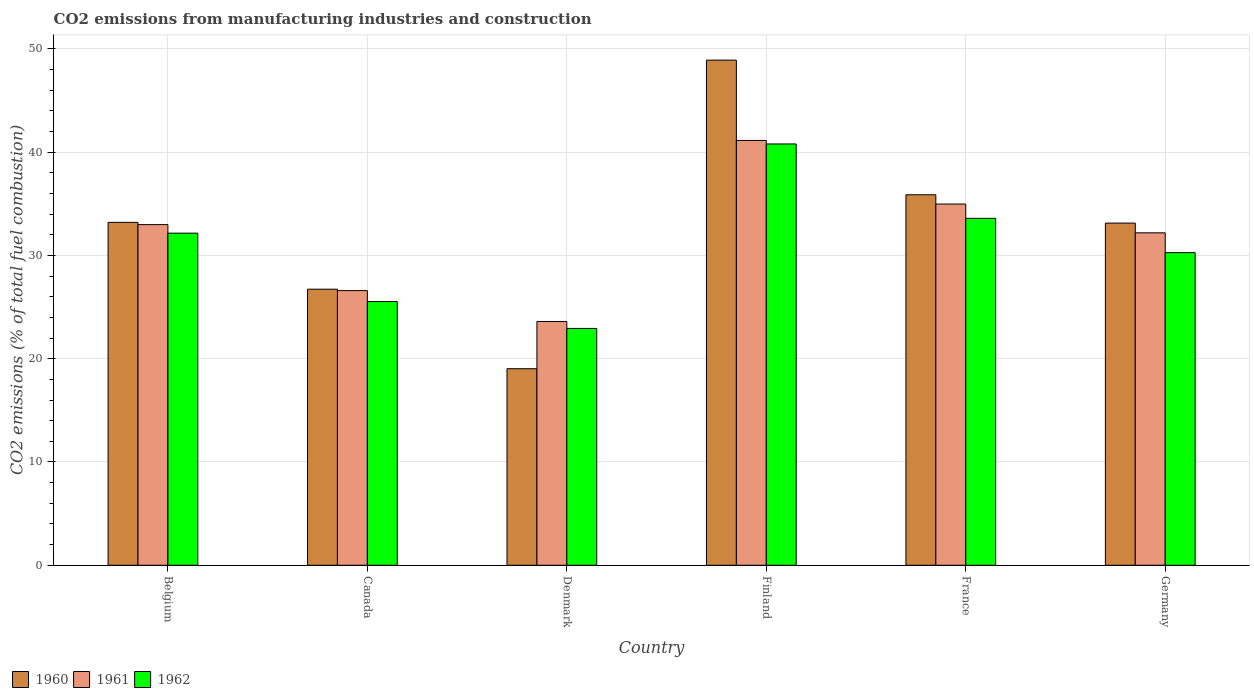How many different coloured bars are there?
Offer a very short reply. 3. Are the number of bars per tick equal to the number of legend labels?
Offer a very short reply. Yes. Are the number of bars on each tick of the X-axis equal?
Offer a very short reply. Yes. How many bars are there on the 2nd tick from the right?
Provide a short and direct response. 3. What is the label of the 3rd group of bars from the left?
Your answer should be very brief. Denmark. In how many cases, is the number of bars for a given country not equal to the number of legend labels?
Your response must be concise. 0. What is the amount of CO2 emitted in 1962 in Germany?
Keep it short and to the point. 30.27. Across all countries, what is the maximum amount of CO2 emitted in 1962?
Give a very brief answer. 40.79. Across all countries, what is the minimum amount of CO2 emitted in 1961?
Make the answer very short. 23.6. What is the total amount of CO2 emitted in 1961 in the graph?
Make the answer very short. 191.47. What is the difference between the amount of CO2 emitted in 1961 in Denmark and that in France?
Offer a very short reply. -11.37. What is the difference between the amount of CO2 emitted in 1960 in France and the amount of CO2 emitted in 1961 in Germany?
Provide a short and direct response. 3.68. What is the average amount of CO2 emitted in 1961 per country?
Offer a terse response. 31.91. What is the difference between the amount of CO2 emitted of/in 1962 and amount of CO2 emitted of/in 1961 in Finland?
Your answer should be compact. -0.34. What is the ratio of the amount of CO2 emitted in 1960 in France to that in Germany?
Offer a very short reply. 1.08. Is the amount of CO2 emitted in 1960 in Belgium less than that in Canada?
Your answer should be very brief. No. Is the difference between the amount of CO2 emitted in 1962 in Denmark and Germany greater than the difference between the amount of CO2 emitted in 1961 in Denmark and Germany?
Provide a succinct answer. Yes. What is the difference between the highest and the second highest amount of CO2 emitted in 1961?
Keep it short and to the point. -8.15. What is the difference between the highest and the lowest amount of CO2 emitted in 1961?
Offer a very short reply. 17.53. Is the sum of the amount of CO2 emitted in 1960 in France and Germany greater than the maximum amount of CO2 emitted in 1961 across all countries?
Offer a terse response. Yes. Is it the case that in every country, the sum of the amount of CO2 emitted in 1962 and amount of CO2 emitted in 1960 is greater than the amount of CO2 emitted in 1961?
Make the answer very short. Yes. Are all the bars in the graph horizontal?
Provide a short and direct response. No. Does the graph contain any zero values?
Ensure brevity in your answer.  No. How many legend labels are there?
Make the answer very short. 3. How are the legend labels stacked?
Your response must be concise. Horizontal. What is the title of the graph?
Offer a terse response. CO2 emissions from manufacturing industries and construction. Does "1960" appear as one of the legend labels in the graph?
Provide a succinct answer. Yes. What is the label or title of the Y-axis?
Keep it short and to the point. CO2 emissions (% of total fuel combustion). What is the CO2 emissions (% of total fuel combustion) in 1960 in Belgium?
Give a very brief answer. 33.2. What is the CO2 emissions (% of total fuel combustion) in 1961 in Belgium?
Provide a short and direct response. 32.98. What is the CO2 emissions (% of total fuel combustion) in 1962 in Belgium?
Your answer should be compact. 32.16. What is the CO2 emissions (% of total fuel combustion) in 1960 in Canada?
Make the answer very short. 26.73. What is the CO2 emissions (% of total fuel combustion) in 1961 in Canada?
Give a very brief answer. 26.59. What is the CO2 emissions (% of total fuel combustion) in 1962 in Canada?
Make the answer very short. 25.53. What is the CO2 emissions (% of total fuel combustion) of 1960 in Denmark?
Provide a short and direct response. 19.03. What is the CO2 emissions (% of total fuel combustion) in 1961 in Denmark?
Keep it short and to the point. 23.6. What is the CO2 emissions (% of total fuel combustion) of 1962 in Denmark?
Your answer should be compact. 22.93. What is the CO2 emissions (% of total fuel combustion) of 1960 in Finland?
Your response must be concise. 48.91. What is the CO2 emissions (% of total fuel combustion) in 1961 in Finland?
Offer a very short reply. 41.13. What is the CO2 emissions (% of total fuel combustion) in 1962 in Finland?
Your answer should be very brief. 40.79. What is the CO2 emissions (% of total fuel combustion) of 1960 in France?
Your answer should be very brief. 35.87. What is the CO2 emissions (% of total fuel combustion) in 1961 in France?
Ensure brevity in your answer.  34.98. What is the CO2 emissions (% of total fuel combustion) in 1962 in France?
Your answer should be very brief. 33.59. What is the CO2 emissions (% of total fuel combustion) of 1960 in Germany?
Offer a terse response. 33.13. What is the CO2 emissions (% of total fuel combustion) in 1961 in Germany?
Offer a very short reply. 32.19. What is the CO2 emissions (% of total fuel combustion) of 1962 in Germany?
Offer a terse response. 30.27. Across all countries, what is the maximum CO2 emissions (% of total fuel combustion) in 1960?
Provide a short and direct response. 48.91. Across all countries, what is the maximum CO2 emissions (% of total fuel combustion) in 1961?
Provide a short and direct response. 41.13. Across all countries, what is the maximum CO2 emissions (% of total fuel combustion) in 1962?
Give a very brief answer. 40.79. Across all countries, what is the minimum CO2 emissions (% of total fuel combustion) in 1960?
Make the answer very short. 19.03. Across all countries, what is the minimum CO2 emissions (% of total fuel combustion) of 1961?
Offer a terse response. 23.6. Across all countries, what is the minimum CO2 emissions (% of total fuel combustion) of 1962?
Keep it short and to the point. 22.93. What is the total CO2 emissions (% of total fuel combustion) of 1960 in the graph?
Make the answer very short. 196.87. What is the total CO2 emissions (% of total fuel combustion) in 1961 in the graph?
Your answer should be compact. 191.47. What is the total CO2 emissions (% of total fuel combustion) in 1962 in the graph?
Make the answer very short. 185.28. What is the difference between the CO2 emissions (% of total fuel combustion) of 1960 in Belgium and that in Canada?
Your answer should be very brief. 6.47. What is the difference between the CO2 emissions (% of total fuel combustion) in 1961 in Belgium and that in Canada?
Your response must be concise. 6.39. What is the difference between the CO2 emissions (% of total fuel combustion) of 1962 in Belgium and that in Canada?
Offer a terse response. 6.62. What is the difference between the CO2 emissions (% of total fuel combustion) in 1960 in Belgium and that in Denmark?
Give a very brief answer. 14.17. What is the difference between the CO2 emissions (% of total fuel combustion) of 1961 in Belgium and that in Denmark?
Your answer should be very brief. 9.38. What is the difference between the CO2 emissions (% of total fuel combustion) of 1962 in Belgium and that in Denmark?
Give a very brief answer. 9.23. What is the difference between the CO2 emissions (% of total fuel combustion) of 1960 in Belgium and that in Finland?
Keep it short and to the point. -15.71. What is the difference between the CO2 emissions (% of total fuel combustion) of 1961 in Belgium and that in Finland?
Ensure brevity in your answer.  -8.15. What is the difference between the CO2 emissions (% of total fuel combustion) of 1962 in Belgium and that in Finland?
Make the answer very short. -8.64. What is the difference between the CO2 emissions (% of total fuel combustion) in 1960 in Belgium and that in France?
Provide a short and direct response. -2.67. What is the difference between the CO2 emissions (% of total fuel combustion) in 1961 in Belgium and that in France?
Offer a terse response. -1.99. What is the difference between the CO2 emissions (% of total fuel combustion) of 1962 in Belgium and that in France?
Your response must be concise. -1.44. What is the difference between the CO2 emissions (% of total fuel combustion) in 1960 in Belgium and that in Germany?
Ensure brevity in your answer.  0.07. What is the difference between the CO2 emissions (% of total fuel combustion) of 1961 in Belgium and that in Germany?
Your answer should be very brief. 0.79. What is the difference between the CO2 emissions (% of total fuel combustion) of 1962 in Belgium and that in Germany?
Keep it short and to the point. 1.88. What is the difference between the CO2 emissions (% of total fuel combustion) of 1960 in Canada and that in Denmark?
Ensure brevity in your answer.  7.7. What is the difference between the CO2 emissions (% of total fuel combustion) in 1961 in Canada and that in Denmark?
Give a very brief answer. 2.99. What is the difference between the CO2 emissions (% of total fuel combustion) in 1962 in Canada and that in Denmark?
Your response must be concise. 2.6. What is the difference between the CO2 emissions (% of total fuel combustion) in 1960 in Canada and that in Finland?
Offer a very short reply. -22.18. What is the difference between the CO2 emissions (% of total fuel combustion) of 1961 in Canada and that in Finland?
Keep it short and to the point. -14.54. What is the difference between the CO2 emissions (% of total fuel combustion) in 1962 in Canada and that in Finland?
Your answer should be compact. -15.26. What is the difference between the CO2 emissions (% of total fuel combustion) in 1960 in Canada and that in France?
Provide a succinct answer. -9.14. What is the difference between the CO2 emissions (% of total fuel combustion) in 1961 in Canada and that in France?
Provide a short and direct response. -8.38. What is the difference between the CO2 emissions (% of total fuel combustion) of 1962 in Canada and that in France?
Your answer should be compact. -8.06. What is the difference between the CO2 emissions (% of total fuel combustion) in 1960 in Canada and that in Germany?
Give a very brief answer. -6.4. What is the difference between the CO2 emissions (% of total fuel combustion) of 1961 in Canada and that in Germany?
Make the answer very short. -5.59. What is the difference between the CO2 emissions (% of total fuel combustion) in 1962 in Canada and that in Germany?
Offer a very short reply. -4.74. What is the difference between the CO2 emissions (% of total fuel combustion) in 1960 in Denmark and that in Finland?
Your answer should be compact. -29.88. What is the difference between the CO2 emissions (% of total fuel combustion) in 1961 in Denmark and that in Finland?
Make the answer very short. -17.53. What is the difference between the CO2 emissions (% of total fuel combustion) of 1962 in Denmark and that in Finland?
Your answer should be compact. -17.86. What is the difference between the CO2 emissions (% of total fuel combustion) in 1960 in Denmark and that in France?
Keep it short and to the point. -16.84. What is the difference between the CO2 emissions (% of total fuel combustion) of 1961 in Denmark and that in France?
Provide a short and direct response. -11.37. What is the difference between the CO2 emissions (% of total fuel combustion) of 1962 in Denmark and that in France?
Provide a short and direct response. -10.66. What is the difference between the CO2 emissions (% of total fuel combustion) in 1960 in Denmark and that in Germany?
Ensure brevity in your answer.  -14.1. What is the difference between the CO2 emissions (% of total fuel combustion) of 1961 in Denmark and that in Germany?
Give a very brief answer. -8.58. What is the difference between the CO2 emissions (% of total fuel combustion) of 1962 in Denmark and that in Germany?
Make the answer very short. -7.34. What is the difference between the CO2 emissions (% of total fuel combustion) of 1960 in Finland and that in France?
Ensure brevity in your answer.  13.04. What is the difference between the CO2 emissions (% of total fuel combustion) in 1961 in Finland and that in France?
Your answer should be compact. 6.16. What is the difference between the CO2 emissions (% of total fuel combustion) of 1962 in Finland and that in France?
Offer a terse response. 7.2. What is the difference between the CO2 emissions (% of total fuel combustion) in 1960 in Finland and that in Germany?
Offer a very short reply. 15.78. What is the difference between the CO2 emissions (% of total fuel combustion) of 1961 in Finland and that in Germany?
Provide a succinct answer. 8.94. What is the difference between the CO2 emissions (% of total fuel combustion) in 1962 in Finland and that in Germany?
Your response must be concise. 10.52. What is the difference between the CO2 emissions (% of total fuel combustion) in 1960 in France and that in Germany?
Offer a very short reply. 2.74. What is the difference between the CO2 emissions (% of total fuel combustion) in 1961 in France and that in Germany?
Your answer should be compact. 2.79. What is the difference between the CO2 emissions (% of total fuel combustion) of 1962 in France and that in Germany?
Your answer should be very brief. 3.32. What is the difference between the CO2 emissions (% of total fuel combustion) of 1960 in Belgium and the CO2 emissions (% of total fuel combustion) of 1961 in Canada?
Offer a very short reply. 6.61. What is the difference between the CO2 emissions (% of total fuel combustion) in 1960 in Belgium and the CO2 emissions (% of total fuel combustion) in 1962 in Canada?
Your answer should be compact. 7.67. What is the difference between the CO2 emissions (% of total fuel combustion) in 1961 in Belgium and the CO2 emissions (% of total fuel combustion) in 1962 in Canada?
Your response must be concise. 7.45. What is the difference between the CO2 emissions (% of total fuel combustion) in 1960 in Belgium and the CO2 emissions (% of total fuel combustion) in 1961 in Denmark?
Provide a short and direct response. 9.6. What is the difference between the CO2 emissions (% of total fuel combustion) of 1960 in Belgium and the CO2 emissions (% of total fuel combustion) of 1962 in Denmark?
Give a very brief answer. 10.27. What is the difference between the CO2 emissions (% of total fuel combustion) of 1961 in Belgium and the CO2 emissions (% of total fuel combustion) of 1962 in Denmark?
Provide a short and direct response. 10.05. What is the difference between the CO2 emissions (% of total fuel combustion) in 1960 in Belgium and the CO2 emissions (% of total fuel combustion) in 1961 in Finland?
Offer a very short reply. -7.93. What is the difference between the CO2 emissions (% of total fuel combustion) in 1960 in Belgium and the CO2 emissions (% of total fuel combustion) in 1962 in Finland?
Your answer should be very brief. -7.59. What is the difference between the CO2 emissions (% of total fuel combustion) in 1961 in Belgium and the CO2 emissions (% of total fuel combustion) in 1962 in Finland?
Provide a short and direct response. -7.81. What is the difference between the CO2 emissions (% of total fuel combustion) of 1960 in Belgium and the CO2 emissions (% of total fuel combustion) of 1961 in France?
Keep it short and to the point. -1.77. What is the difference between the CO2 emissions (% of total fuel combustion) in 1960 in Belgium and the CO2 emissions (% of total fuel combustion) in 1962 in France?
Your response must be concise. -0.39. What is the difference between the CO2 emissions (% of total fuel combustion) in 1961 in Belgium and the CO2 emissions (% of total fuel combustion) in 1962 in France?
Your response must be concise. -0.61. What is the difference between the CO2 emissions (% of total fuel combustion) in 1960 in Belgium and the CO2 emissions (% of total fuel combustion) in 1961 in Germany?
Give a very brief answer. 1.01. What is the difference between the CO2 emissions (% of total fuel combustion) of 1960 in Belgium and the CO2 emissions (% of total fuel combustion) of 1962 in Germany?
Keep it short and to the point. 2.93. What is the difference between the CO2 emissions (% of total fuel combustion) in 1961 in Belgium and the CO2 emissions (% of total fuel combustion) in 1962 in Germany?
Ensure brevity in your answer.  2.71. What is the difference between the CO2 emissions (% of total fuel combustion) of 1960 in Canada and the CO2 emissions (% of total fuel combustion) of 1961 in Denmark?
Keep it short and to the point. 3.13. What is the difference between the CO2 emissions (% of total fuel combustion) of 1960 in Canada and the CO2 emissions (% of total fuel combustion) of 1962 in Denmark?
Give a very brief answer. 3.8. What is the difference between the CO2 emissions (% of total fuel combustion) in 1961 in Canada and the CO2 emissions (% of total fuel combustion) in 1962 in Denmark?
Your answer should be compact. 3.66. What is the difference between the CO2 emissions (% of total fuel combustion) in 1960 in Canada and the CO2 emissions (% of total fuel combustion) in 1961 in Finland?
Offer a terse response. -14.4. What is the difference between the CO2 emissions (% of total fuel combustion) of 1960 in Canada and the CO2 emissions (% of total fuel combustion) of 1962 in Finland?
Your response must be concise. -14.06. What is the difference between the CO2 emissions (% of total fuel combustion) in 1961 in Canada and the CO2 emissions (% of total fuel combustion) in 1962 in Finland?
Your answer should be very brief. -14.2. What is the difference between the CO2 emissions (% of total fuel combustion) in 1960 in Canada and the CO2 emissions (% of total fuel combustion) in 1961 in France?
Provide a short and direct response. -8.24. What is the difference between the CO2 emissions (% of total fuel combustion) of 1960 in Canada and the CO2 emissions (% of total fuel combustion) of 1962 in France?
Your answer should be compact. -6.86. What is the difference between the CO2 emissions (% of total fuel combustion) in 1961 in Canada and the CO2 emissions (% of total fuel combustion) in 1962 in France?
Provide a short and direct response. -7. What is the difference between the CO2 emissions (% of total fuel combustion) in 1960 in Canada and the CO2 emissions (% of total fuel combustion) in 1961 in Germany?
Your answer should be very brief. -5.46. What is the difference between the CO2 emissions (% of total fuel combustion) in 1960 in Canada and the CO2 emissions (% of total fuel combustion) in 1962 in Germany?
Offer a terse response. -3.54. What is the difference between the CO2 emissions (% of total fuel combustion) in 1961 in Canada and the CO2 emissions (% of total fuel combustion) in 1962 in Germany?
Your response must be concise. -3.68. What is the difference between the CO2 emissions (% of total fuel combustion) of 1960 in Denmark and the CO2 emissions (% of total fuel combustion) of 1961 in Finland?
Provide a short and direct response. -22.1. What is the difference between the CO2 emissions (% of total fuel combustion) in 1960 in Denmark and the CO2 emissions (% of total fuel combustion) in 1962 in Finland?
Offer a very short reply. -21.76. What is the difference between the CO2 emissions (% of total fuel combustion) in 1961 in Denmark and the CO2 emissions (% of total fuel combustion) in 1962 in Finland?
Your answer should be very brief. -17.19. What is the difference between the CO2 emissions (% of total fuel combustion) of 1960 in Denmark and the CO2 emissions (% of total fuel combustion) of 1961 in France?
Your answer should be compact. -15.95. What is the difference between the CO2 emissions (% of total fuel combustion) in 1960 in Denmark and the CO2 emissions (% of total fuel combustion) in 1962 in France?
Keep it short and to the point. -14.56. What is the difference between the CO2 emissions (% of total fuel combustion) of 1961 in Denmark and the CO2 emissions (% of total fuel combustion) of 1962 in France?
Provide a succinct answer. -9.99. What is the difference between the CO2 emissions (% of total fuel combustion) in 1960 in Denmark and the CO2 emissions (% of total fuel combustion) in 1961 in Germany?
Provide a short and direct response. -13.16. What is the difference between the CO2 emissions (% of total fuel combustion) in 1960 in Denmark and the CO2 emissions (% of total fuel combustion) in 1962 in Germany?
Keep it short and to the point. -11.24. What is the difference between the CO2 emissions (% of total fuel combustion) in 1961 in Denmark and the CO2 emissions (% of total fuel combustion) in 1962 in Germany?
Offer a very short reply. -6.67. What is the difference between the CO2 emissions (% of total fuel combustion) in 1960 in Finland and the CO2 emissions (% of total fuel combustion) in 1961 in France?
Offer a very short reply. 13.93. What is the difference between the CO2 emissions (% of total fuel combustion) of 1960 in Finland and the CO2 emissions (% of total fuel combustion) of 1962 in France?
Offer a terse response. 15.32. What is the difference between the CO2 emissions (% of total fuel combustion) of 1961 in Finland and the CO2 emissions (% of total fuel combustion) of 1962 in France?
Your response must be concise. 7.54. What is the difference between the CO2 emissions (% of total fuel combustion) in 1960 in Finland and the CO2 emissions (% of total fuel combustion) in 1961 in Germany?
Make the answer very short. 16.72. What is the difference between the CO2 emissions (% of total fuel combustion) of 1960 in Finland and the CO2 emissions (% of total fuel combustion) of 1962 in Germany?
Your answer should be very brief. 18.64. What is the difference between the CO2 emissions (% of total fuel combustion) of 1961 in Finland and the CO2 emissions (% of total fuel combustion) of 1962 in Germany?
Offer a very short reply. 10.86. What is the difference between the CO2 emissions (% of total fuel combustion) of 1960 in France and the CO2 emissions (% of total fuel combustion) of 1961 in Germany?
Ensure brevity in your answer.  3.68. What is the difference between the CO2 emissions (% of total fuel combustion) in 1960 in France and the CO2 emissions (% of total fuel combustion) in 1962 in Germany?
Provide a succinct answer. 5.6. What is the difference between the CO2 emissions (% of total fuel combustion) of 1961 in France and the CO2 emissions (% of total fuel combustion) of 1962 in Germany?
Make the answer very short. 4.7. What is the average CO2 emissions (% of total fuel combustion) of 1960 per country?
Provide a succinct answer. 32.81. What is the average CO2 emissions (% of total fuel combustion) in 1961 per country?
Offer a terse response. 31.91. What is the average CO2 emissions (% of total fuel combustion) in 1962 per country?
Make the answer very short. 30.88. What is the difference between the CO2 emissions (% of total fuel combustion) of 1960 and CO2 emissions (% of total fuel combustion) of 1961 in Belgium?
Keep it short and to the point. 0.22. What is the difference between the CO2 emissions (% of total fuel combustion) in 1960 and CO2 emissions (% of total fuel combustion) in 1962 in Belgium?
Your answer should be compact. 1.04. What is the difference between the CO2 emissions (% of total fuel combustion) of 1961 and CO2 emissions (% of total fuel combustion) of 1962 in Belgium?
Provide a succinct answer. 0.83. What is the difference between the CO2 emissions (% of total fuel combustion) in 1960 and CO2 emissions (% of total fuel combustion) in 1961 in Canada?
Your answer should be compact. 0.14. What is the difference between the CO2 emissions (% of total fuel combustion) in 1960 and CO2 emissions (% of total fuel combustion) in 1962 in Canada?
Offer a terse response. 1.2. What is the difference between the CO2 emissions (% of total fuel combustion) in 1961 and CO2 emissions (% of total fuel combustion) in 1962 in Canada?
Make the answer very short. 1.06. What is the difference between the CO2 emissions (% of total fuel combustion) of 1960 and CO2 emissions (% of total fuel combustion) of 1961 in Denmark?
Give a very brief answer. -4.57. What is the difference between the CO2 emissions (% of total fuel combustion) of 1960 and CO2 emissions (% of total fuel combustion) of 1962 in Denmark?
Ensure brevity in your answer.  -3.9. What is the difference between the CO2 emissions (% of total fuel combustion) in 1961 and CO2 emissions (% of total fuel combustion) in 1962 in Denmark?
Make the answer very short. 0.67. What is the difference between the CO2 emissions (% of total fuel combustion) of 1960 and CO2 emissions (% of total fuel combustion) of 1961 in Finland?
Provide a succinct answer. 7.78. What is the difference between the CO2 emissions (% of total fuel combustion) of 1960 and CO2 emissions (% of total fuel combustion) of 1962 in Finland?
Provide a succinct answer. 8.12. What is the difference between the CO2 emissions (% of total fuel combustion) of 1961 and CO2 emissions (% of total fuel combustion) of 1962 in Finland?
Your response must be concise. 0.34. What is the difference between the CO2 emissions (% of total fuel combustion) of 1960 and CO2 emissions (% of total fuel combustion) of 1961 in France?
Keep it short and to the point. 0.9. What is the difference between the CO2 emissions (% of total fuel combustion) in 1960 and CO2 emissions (% of total fuel combustion) in 1962 in France?
Ensure brevity in your answer.  2.28. What is the difference between the CO2 emissions (% of total fuel combustion) in 1961 and CO2 emissions (% of total fuel combustion) in 1962 in France?
Offer a terse response. 1.38. What is the difference between the CO2 emissions (% of total fuel combustion) in 1960 and CO2 emissions (% of total fuel combustion) in 1961 in Germany?
Your response must be concise. 0.94. What is the difference between the CO2 emissions (% of total fuel combustion) in 1960 and CO2 emissions (% of total fuel combustion) in 1962 in Germany?
Offer a very short reply. 2.86. What is the difference between the CO2 emissions (% of total fuel combustion) in 1961 and CO2 emissions (% of total fuel combustion) in 1962 in Germany?
Offer a very short reply. 1.92. What is the ratio of the CO2 emissions (% of total fuel combustion) in 1960 in Belgium to that in Canada?
Your answer should be compact. 1.24. What is the ratio of the CO2 emissions (% of total fuel combustion) of 1961 in Belgium to that in Canada?
Make the answer very short. 1.24. What is the ratio of the CO2 emissions (% of total fuel combustion) of 1962 in Belgium to that in Canada?
Keep it short and to the point. 1.26. What is the ratio of the CO2 emissions (% of total fuel combustion) in 1960 in Belgium to that in Denmark?
Make the answer very short. 1.74. What is the ratio of the CO2 emissions (% of total fuel combustion) of 1961 in Belgium to that in Denmark?
Offer a very short reply. 1.4. What is the ratio of the CO2 emissions (% of total fuel combustion) in 1962 in Belgium to that in Denmark?
Your response must be concise. 1.4. What is the ratio of the CO2 emissions (% of total fuel combustion) of 1960 in Belgium to that in Finland?
Offer a very short reply. 0.68. What is the ratio of the CO2 emissions (% of total fuel combustion) of 1961 in Belgium to that in Finland?
Your response must be concise. 0.8. What is the ratio of the CO2 emissions (% of total fuel combustion) of 1962 in Belgium to that in Finland?
Give a very brief answer. 0.79. What is the ratio of the CO2 emissions (% of total fuel combustion) in 1960 in Belgium to that in France?
Ensure brevity in your answer.  0.93. What is the ratio of the CO2 emissions (% of total fuel combustion) in 1961 in Belgium to that in France?
Offer a terse response. 0.94. What is the ratio of the CO2 emissions (% of total fuel combustion) in 1962 in Belgium to that in France?
Your answer should be compact. 0.96. What is the ratio of the CO2 emissions (% of total fuel combustion) of 1961 in Belgium to that in Germany?
Make the answer very short. 1.02. What is the ratio of the CO2 emissions (% of total fuel combustion) in 1962 in Belgium to that in Germany?
Ensure brevity in your answer.  1.06. What is the ratio of the CO2 emissions (% of total fuel combustion) in 1960 in Canada to that in Denmark?
Ensure brevity in your answer.  1.4. What is the ratio of the CO2 emissions (% of total fuel combustion) in 1961 in Canada to that in Denmark?
Give a very brief answer. 1.13. What is the ratio of the CO2 emissions (% of total fuel combustion) of 1962 in Canada to that in Denmark?
Give a very brief answer. 1.11. What is the ratio of the CO2 emissions (% of total fuel combustion) of 1960 in Canada to that in Finland?
Your answer should be compact. 0.55. What is the ratio of the CO2 emissions (% of total fuel combustion) in 1961 in Canada to that in Finland?
Give a very brief answer. 0.65. What is the ratio of the CO2 emissions (% of total fuel combustion) of 1962 in Canada to that in Finland?
Provide a short and direct response. 0.63. What is the ratio of the CO2 emissions (% of total fuel combustion) of 1960 in Canada to that in France?
Make the answer very short. 0.75. What is the ratio of the CO2 emissions (% of total fuel combustion) of 1961 in Canada to that in France?
Keep it short and to the point. 0.76. What is the ratio of the CO2 emissions (% of total fuel combustion) in 1962 in Canada to that in France?
Your answer should be compact. 0.76. What is the ratio of the CO2 emissions (% of total fuel combustion) of 1960 in Canada to that in Germany?
Offer a terse response. 0.81. What is the ratio of the CO2 emissions (% of total fuel combustion) of 1961 in Canada to that in Germany?
Offer a terse response. 0.83. What is the ratio of the CO2 emissions (% of total fuel combustion) of 1962 in Canada to that in Germany?
Give a very brief answer. 0.84. What is the ratio of the CO2 emissions (% of total fuel combustion) in 1960 in Denmark to that in Finland?
Ensure brevity in your answer.  0.39. What is the ratio of the CO2 emissions (% of total fuel combustion) of 1961 in Denmark to that in Finland?
Make the answer very short. 0.57. What is the ratio of the CO2 emissions (% of total fuel combustion) in 1962 in Denmark to that in Finland?
Provide a succinct answer. 0.56. What is the ratio of the CO2 emissions (% of total fuel combustion) of 1960 in Denmark to that in France?
Make the answer very short. 0.53. What is the ratio of the CO2 emissions (% of total fuel combustion) in 1961 in Denmark to that in France?
Give a very brief answer. 0.67. What is the ratio of the CO2 emissions (% of total fuel combustion) of 1962 in Denmark to that in France?
Make the answer very short. 0.68. What is the ratio of the CO2 emissions (% of total fuel combustion) of 1960 in Denmark to that in Germany?
Keep it short and to the point. 0.57. What is the ratio of the CO2 emissions (% of total fuel combustion) of 1961 in Denmark to that in Germany?
Give a very brief answer. 0.73. What is the ratio of the CO2 emissions (% of total fuel combustion) in 1962 in Denmark to that in Germany?
Your response must be concise. 0.76. What is the ratio of the CO2 emissions (% of total fuel combustion) in 1960 in Finland to that in France?
Your answer should be very brief. 1.36. What is the ratio of the CO2 emissions (% of total fuel combustion) in 1961 in Finland to that in France?
Provide a succinct answer. 1.18. What is the ratio of the CO2 emissions (% of total fuel combustion) in 1962 in Finland to that in France?
Provide a succinct answer. 1.21. What is the ratio of the CO2 emissions (% of total fuel combustion) of 1960 in Finland to that in Germany?
Keep it short and to the point. 1.48. What is the ratio of the CO2 emissions (% of total fuel combustion) in 1961 in Finland to that in Germany?
Offer a terse response. 1.28. What is the ratio of the CO2 emissions (% of total fuel combustion) in 1962 in Finland to that in Germany?
Your answer should be very brief. 1.35. What is the ratio of the CO2 emissions (% of total fuel combustion) in 1960 in France to that in Germany?
Keep it short and to the point. 1.08. What is the ratio of the CO2 emissions (% of total fuel combustion) in 1961 in France to that in Germany?
Offer a terse response. 1.09. What is the ratio of the CO2 emissions (% of total fuel combustion) in 1962 in France to that in Germany?
Ensure brevity in your answer.  1.11. What is the difference between the highest and the second highest CO2 emissions (% of total fuel combustion) in 1960?
Your answer should be very brief. 13.04. What is the difference between the highest and the second highest CO2 emissions (% of total fuel combustion) of 1961?
Your answer should be compact. 6.16. What is the difference between the highest and the second highest CO2 emissions (% of total fuel combustion) of 1962?
Provide a succinct answer. 7.2. What is the difference between the highest and the lowest CO2 emissions (% of total fuel combustion) of 1960?
Provide a short and direct response. 29.88. What is the difference between the highest and the lowest CO2 emissions (% of total fuel combustion) in 1961?
Make the answer very short. 17.53. What is the difference between the highest and the lowest CO2 emissions (% of total fuel combustion) in 1962?
Your answer should be compact. 17.86. 